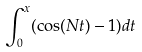Convert formula to latex. <formula><loc_0><loc_0><loc_500><loc_500>\int _ { 0 } ^ { x } ( \cos ( N t ) - 1 ) d t</formula> 